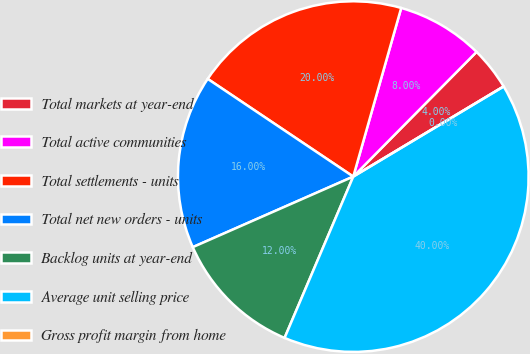Convert chart to OTSL. <chart><loc_0><loc_0><loc_500><loc_500><pie_chart><fcel>Total markets at year-end<fcel>Total active communities<fcel>Total settlements - units<fcel>Total net new orders - units<fcel>Backlog units at year-end<fcel>Average unit selling price<fcel>Gross profit margin from home<nl><fcel>4.0%<fcel>8.0%<fcel>20.0%<fcel>16.0%<fcel>12.0%<fcel>40.0%<fcel>0.0%<nl></chart> 